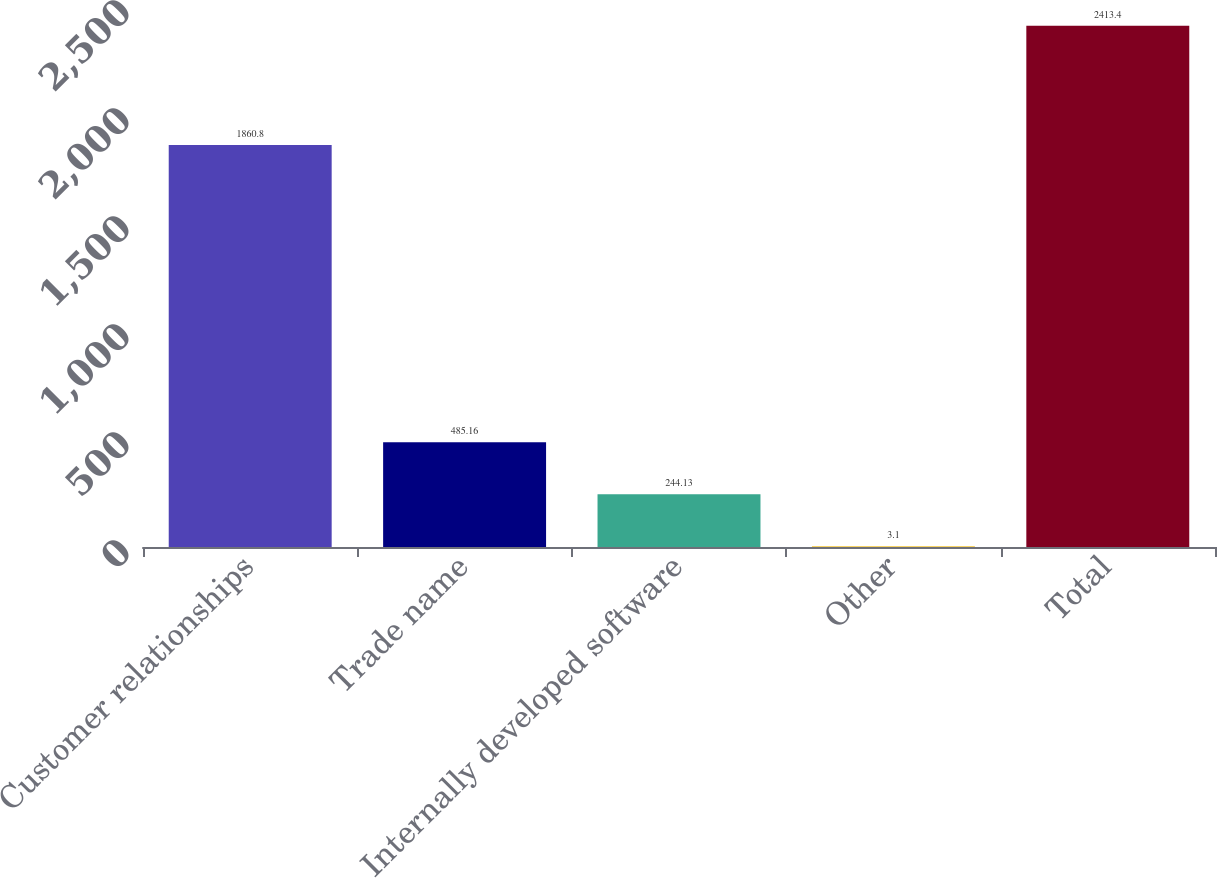Convert chart. <chart><loc_0><loc_0><loc_500><loc_500><bar_chart><fcel>Customer relationships<fcel>Trade name<fcel>Internally developed software<fcel>Other<fcel>Total<nl><fcel>1860.8<fcel>485.16<fcel>244.13<fcel>3.1<fcel>2413.4<nl></chart> 